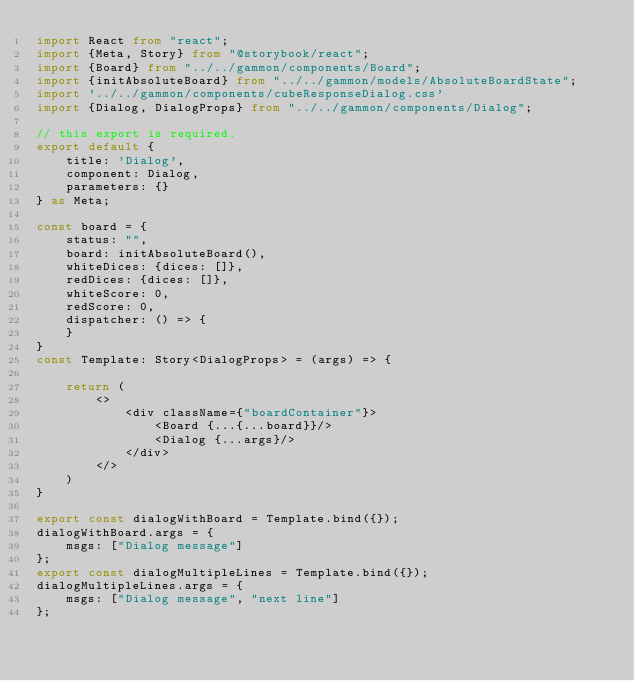<code> <loc_0><loc_0><loc_500><loc_500><_TypeScript_>import React from "react";
import {Meta, Story} from "@storybook/react";
import {Board} from "../../gammon/components/Board";
import {initAbsoluteBoard} from "../../gammon/models/AbsoluteBoardState";
import '../../gammon/components/cubeResponseDialog.css'
import {Dialog, DialogProps} from "../../gammon/components/Dialog";

// this export is required.
export default {
    title: 'Dialog',
    component: Dialog,
    parameters: {}
} as Meta;

const board = {
    status: "",
    board: initAbsoluteBoard(),
    whiteDices: {dices: []},
    redDices: {dices: []},
    whiteScore: 0,
    redScore: 0,
    dispatcher: () => {
    }
}
const Template: Story<DialogProps> = (args) => {

    return (
        <>
            <div className={"boardContainer"}>
                <Board {...{...board}}/>
                <Dialog {...args}/>
            </div>
        </>
    )
}

export const dialogWithBoard = Template.bind({});
dialogWithBoard.args = {
    msgs: ["Dialog message"]
};
export const dialogMultipleLines = Template.bind({});
dialogMultipleLines.args = {
    msgs: ["Dialog message", "next line"]
};
</code> 